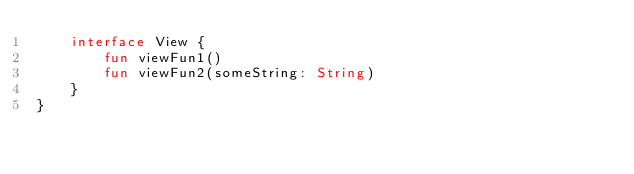<code> <loc_0><loc_0><loc_500><loc_500><_Kotlin_>    interface View {
        fun viewFun1()
        fun viewFun2(someString: String)
    }
}
</code> 